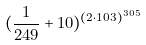Convert formula to latex. <formula><loc_0><loc_0><loc_500><loc_500>( \frac { 1 } { 2 4 9 } + 1 0 ) ^ { ( 2 \cdot 1 0 3 ) ^ { 3 0 5 } }</formula> 